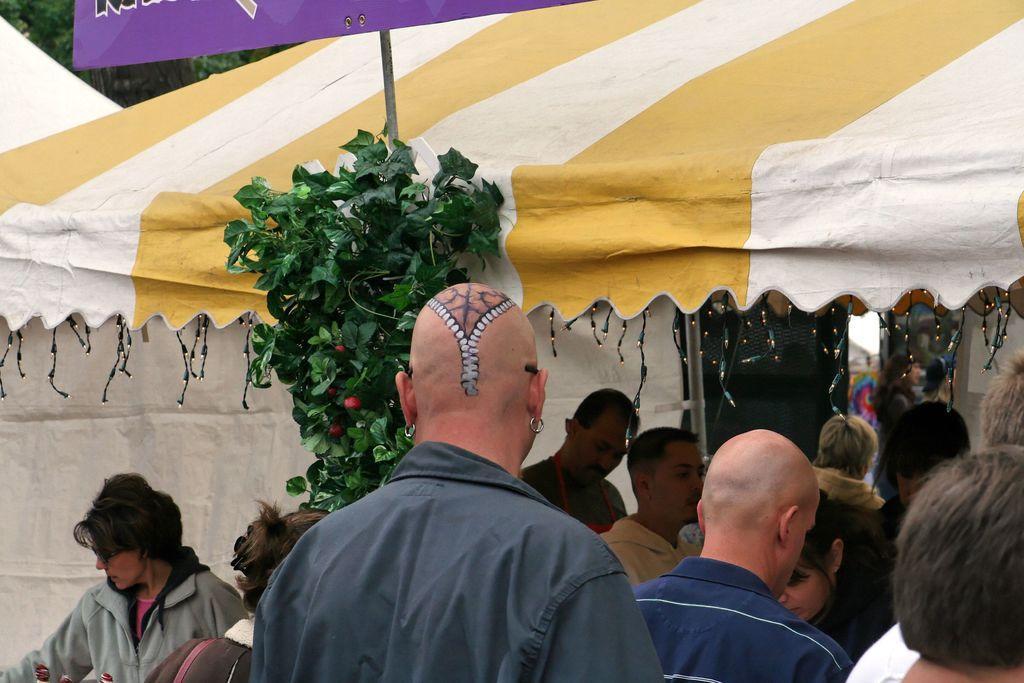Can you describe this image briefly? In front of the image there is a head of a man with a painting on it. And there are many people standing. In between them there is a pole with a plant and also there is a board. In the background there is a tent with a pole and also there are decorative lights. 